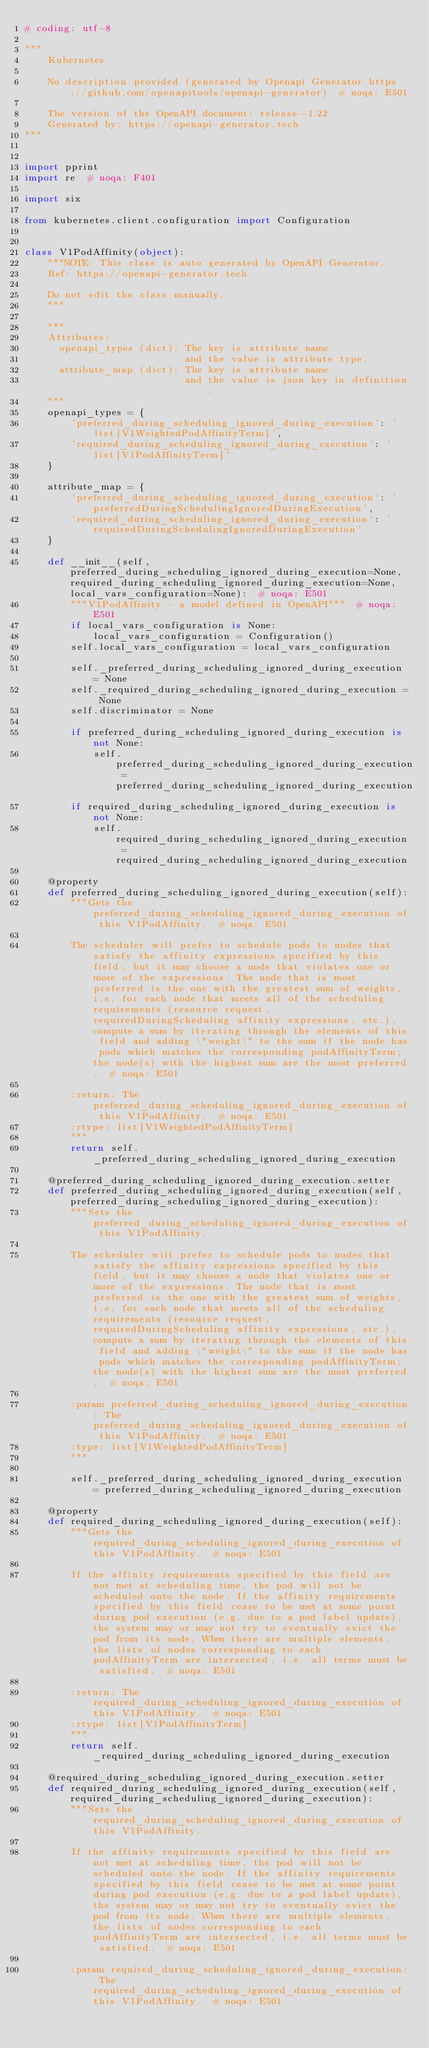Convert code to text. <code><loc_0><loc_0><loc_500><loc_500><_Python_># coding: utf-8

"""
    Kubernetes

    No description provided (generated by Openapi Generator https://github.com/openapitools/openapi-generator)  # noqa: E501

    The version of the OpenAPI document: release-1.22
    Generated by: https://openapi-generator.tech
"""


import pprint
import re  # noqa: F401

import six

from kubernetes.client.configuration import Configuration


class V1PodAffinity(object):
    """NOTE: This class is auto generated by OpenAPI Generator.
    Ref: https://openapi-generator.tech

    Do not edit the class manually.
    """

    """
    Attributes:
      openapi_types (dict): The key is attribute name
                            and the value is attribute type.
      attribute_map (dict): The key is attribute name
                            and the value is json key in definition.
    """
    openapi_types = {
        'preferred_during_scheduling_ignored_during_execution': 'list[V1WeightedPodAffinityTerm]',
        'required_during_scheduling_ignored_during_execution': 'list[V1PodAffinityTerm]'
    }

    attribute_map = {
        'preferred_during_scheduling_ignored_during_execution': 'preferredDuringSchedulingIgnoredDuringExecution',
        'required_during_scheduling_ignored_during_execution': 'requiredDuringSchedulingIgnoredDuringExecution'
    }

    def __init__(self, preferred_during_scheduling_ignored_during_execution=None, required_during_scheduling_ignored_during_execution=None, local_vars_configuration=None):  # noqa: E501
        """V1PodAffinity - a model defined in OpenAPI"""  # noqa: E501
        if local_vars_configuration is None:
            local_vars_configuration = Configuration()
        self.local_vars_configuration = local_vars_configuration

        self._preferred_during_scheduling_ignored_during_execution = None
        self._required_during_scheduling_ignored_during_execution = None
        self.discriminator = None

        if preferred_during_scheduling_ignored_during_execution is not None:
            self.preferred_during_scheduling_ignored_during_execution = preferred_during_scheduling_ignored_during_execution
        if required_during_scheduling_ignored_during_execution is not None:
            self.required_during_scheduling_ignored_during_execution = required_during_scheduling_ignored_during_execution

    @property
    def preferred_during_scheduling_ignored_during_execution(self):
        """Gets the preferred_during_scheduling_ignored_during_execution of this V1PodAffinity.  # noqa: E501

        The scheduler will prefer to schedule pods to nodes that satisfy the affinity expressions specified by this field, but it may choose a node that violates one or more of the expressions. The node that is most preferred is the one with the greatest sum of weights, i.e. for each node that meets all of the scheduling requirements (resource request, requiredDuringScheduling affinity expressions, etc.), compute a sum by iterating through the elements of this field and adding \"weight\" to the sum if the node has pods which matches the corresponding podAffinityTerm; the node(s) with the highest sum are the most preferred.  # noqa: E501

        :return: The preferred_during_scheduling_ignored_during_execution of this V1PodAffinity.  # noqa: E501
        :rtype: list[V1WeightedPodAffinityTerm]
        """
        return self._preferred_during_scheduling_ignored_during_execution

    @preferred_during_scheduling_ignored_during_execution.setter
    def preferred_during_scheduling_ignored_during_execution(self, preferred_during_scheduling_ignored_during_execution):
        """Sets the preferred_during_scheduling_ignored_during_execution of this V1PodAffinity.

        The scheduler will prefer to schedule pods to nodes that satisfy the affinity expressions specified by this field, but it may choose a node that violates one or more of the expressions. The node that is most preferred is the one with the greatest sum of weights, i.e. for each node that meets all of the scheduling requirements (resource request, requiredDuringScheduling affinity expressions, etc.), compute a sum by iterating through the elements of this field and adding \"weight\" to the sum if the node has pods which matches the corresponding podAffinityTerm; the node(s) with the highest sum are the most preferred.  # noqa: E501

        :param preferred_during_scheduling_ignored_during_execution: The preferred_during_scheduling_ignored_during_execution of this V1PodAffinity.  # noqa: E501
        :type: list[V1WeightedPodAffinityTerm]
        """

        self._preferred_during_scheduling_ignored_during_execution = preferred_during_scheduling_ignored_during_execution

    @property
    def required_during_scheduling_ignored_during_execution(self):
        """Gets the required_during_scheduling_ignored_during_execution of this V1PodAffinity.  # noqa: E501

        If the affinity requirements specified by this field are not met at scheduling time, the pod will not be scheduled onto the node. If the affinity requirements specified by this field cease to be met at some point during pod execution (e.g. due to a pod label update), the system may or may not try to eventually evict the pod from its node. When there are multiple elements, the lists of nodes corresponding to each podAffinityTerm are intersected, i.e. all terms must be satisfied.  # noqa: E501

        :return: The required_during_scheduling_ignored_during_execution of this V1PodAffinity.  # noqa: E501
        :rtype: list[V1PodAffinityTerm]
        """
        return self._required_during_scheduling_ignored_during_execution

    @required_during_scheduling_ignored_during_execution.setter
    def required_during_scheduling_ignored_during_execution(self, required_during_scheduling_ignored_during_execution):
        """Sets the required_during_scheduling_ignored_during_execution of this V1PodAffinity.

        If the affinity requirements specified by this field are not met at scheduling time, the pod will not be scheduled onto the node. If the affinity requirements specified by this field cease to be met at some point during pod execution (e.g. due to a pod label update), the system may or may not try to eventually evict the pod from its node. When there are multiple elements, the lists of nodes corresponding to each podAffinityTerm are intersected, i.e. all terms must be satisfied.  # noqa: E501

        :param required_during_scheduling_ignored_during_execution: The required_during_scheduling_ignored_during_execution of this V1PodAffinity.  # noqa: E501</code> 